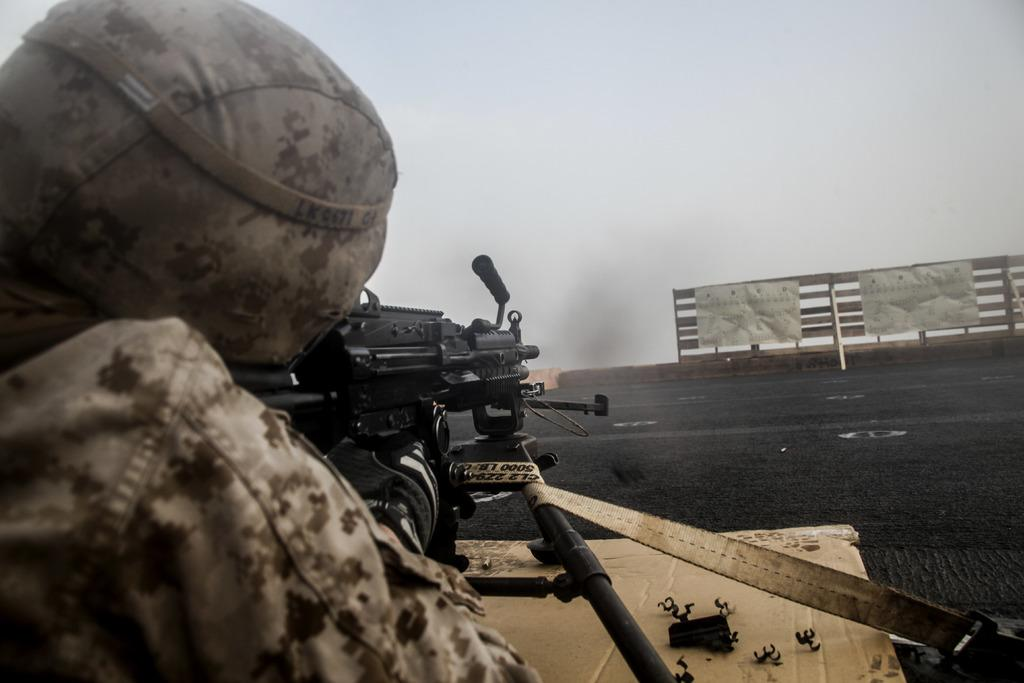What is the person in the center of the image holding? There is a person holding an object in the center of the image. What can be seen in the distance behind the person? The sky, clouds, posters, and a fence are visible in the background of the image. Can you describe the sky in the image? The sky is visible in the background of the image. How does the person in the image shake the object they are holding? There is no indication in the image that the person is shaking the object they are holding. 